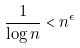<formula> <loc_0><loc_0><loc_500><loc_500>\frac { 1 } { \log n } < n ^ { \epsilon }</formula> 